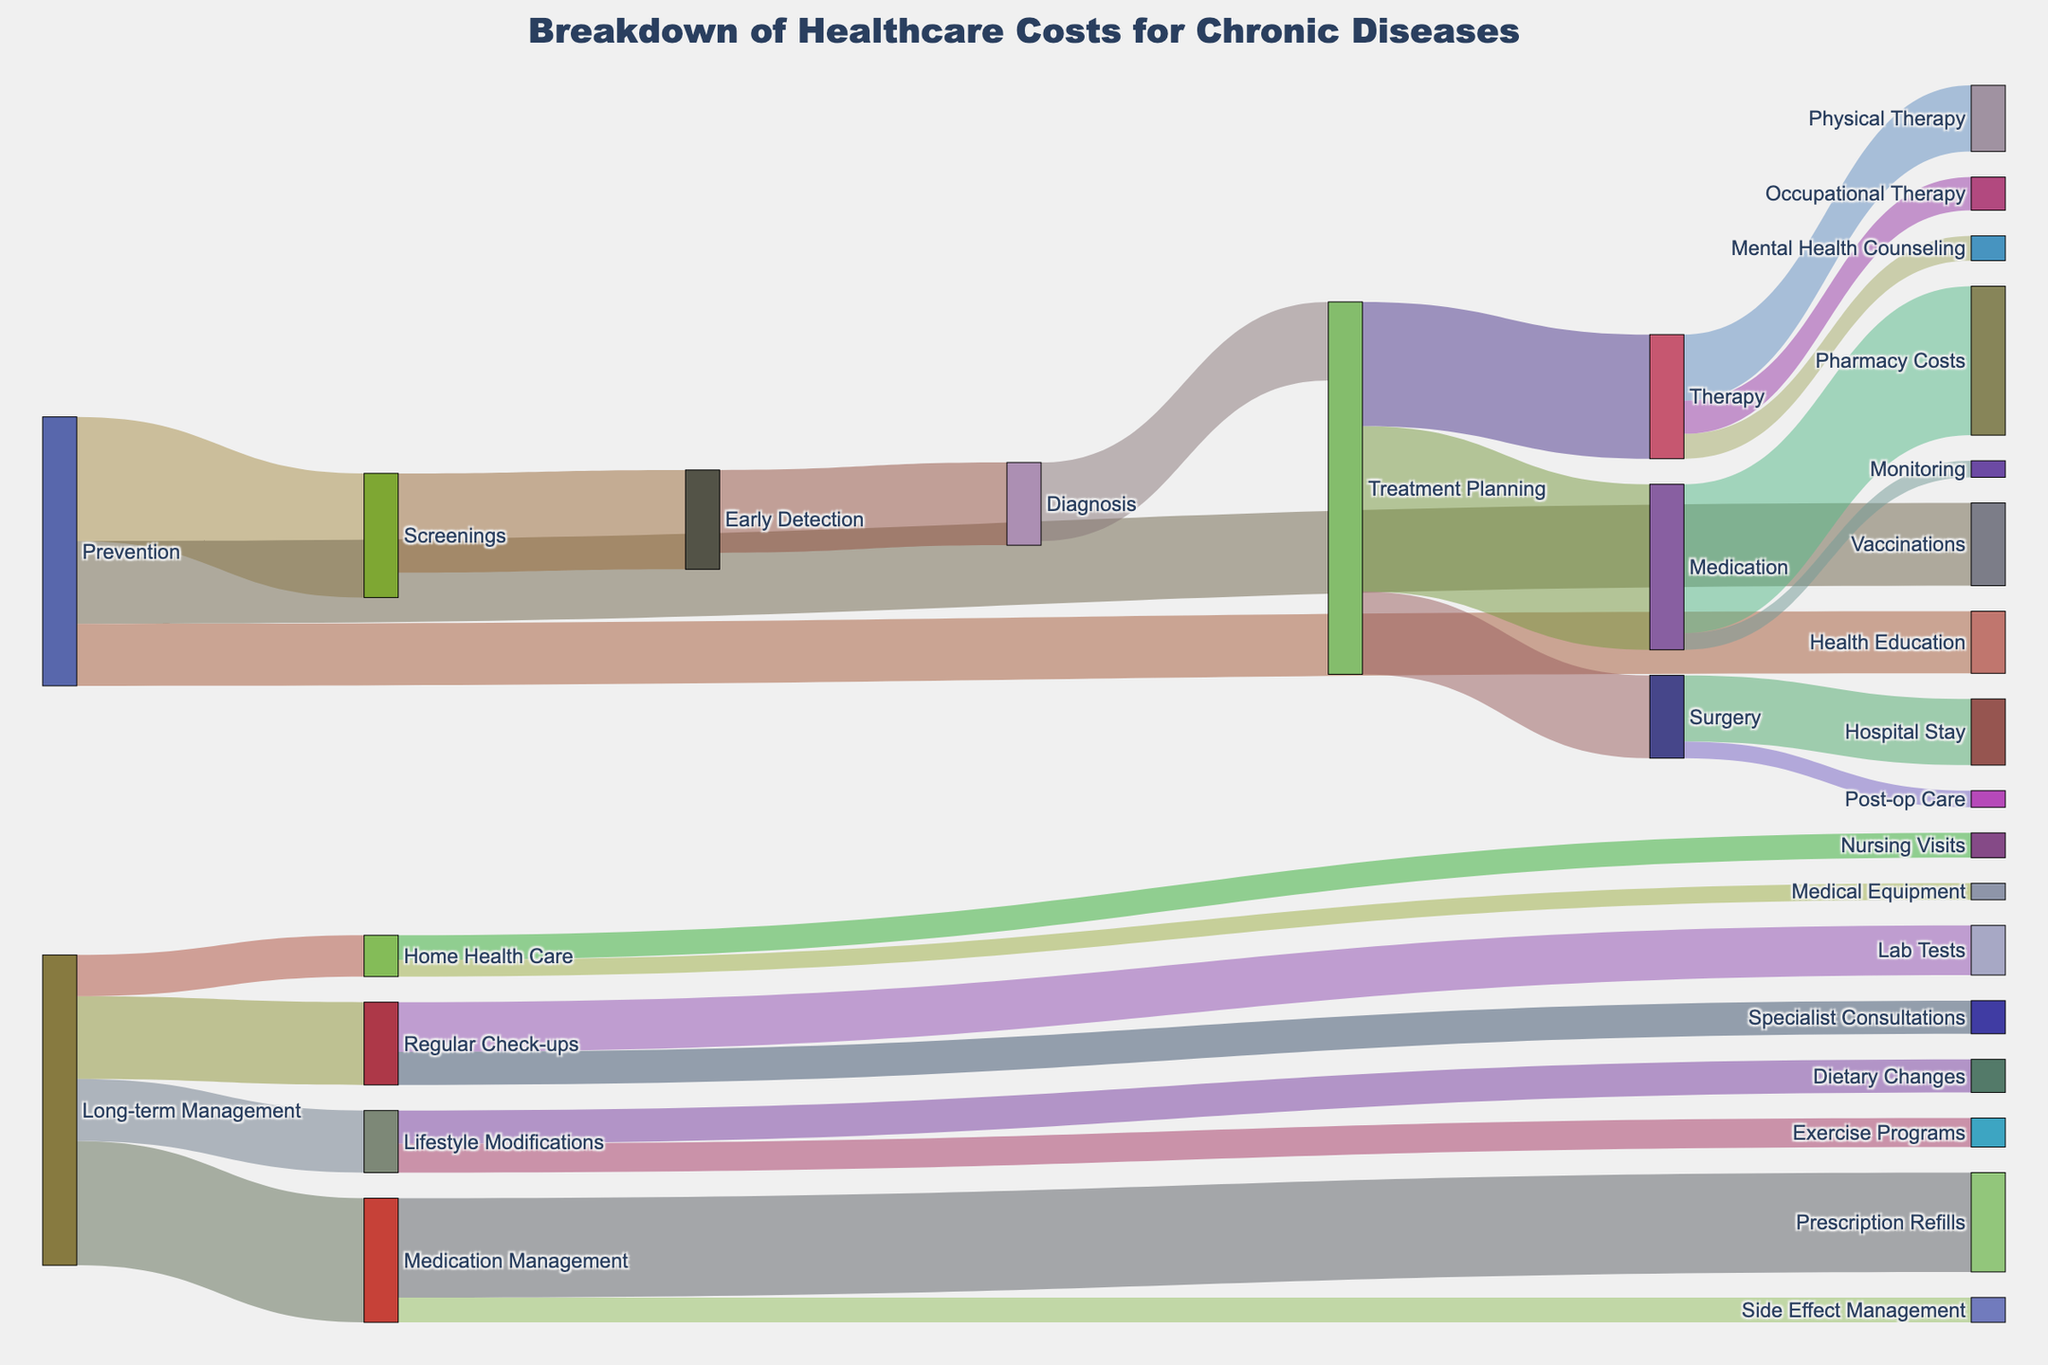What is the highest cost item within the "Long-term Management" section? First, identify the targets under "Long-term Management" which are "Regular Check-ups," "Medication Management," "Lifestyle Modifications," and "Home Health Care." The costs are 100, 150, 75, and 50 respectively. "Medication Management" has the highest cost of 150.
Answer: Medication Management What is the total cost spent on "Prevention"? Add the values of all targets linked to "Prevention": Screenings (150), Vaccinations (100), and Health Education (75). The total cost is 150 + 100 + 75 = 325.
Answer: 325 Which transition has the lowest cost within the "Therapy" section? Identify the transitions under "Therapy": Physical Therapy (80), Occupational Therapy (40), and Mental Health Counseling (30). The lowest cost is for Mental Health Counseling at 30.
Answer: Mental Health Counseling What is the total cost of "Treatment Planning"? Add the values of all targets linked to "Treatment Planning": Medication (200), Therapy (150), and Surgery (100). The total cost is 200 + 150 + 100 = 450.
Answer: 450 How does the cost of "Hospital Stay" compare to "Nursing Visits"? Identify the costs for "Hospital Stay" (80) and "Nursing Visits" (30). "Hospital Stay" is higher than "Nursing Visits".
Answer: Hospital Stay is higher What is the cumulative cost of all "Therapy" activities? Add the values of all transitions within "Therapy": Physical Therapy (80), Occupational Therapy (40), and Mental Health Counseling (30). The total cumulative cost is 80 + 40 + 30 = 150.
Answer: 150 What portion of the costs under "Medication" is attributed to "Pharmacy Costs"? Identify the costs under "Medication": Pharmacy Costs (180) and Monitoring (20). The portion attributed to Pharmacy Costs is 180 out of a total of 200, which is 180/200 = 90%.
Answer: 90% What is the cost difference between "Early Detection" and "Diagnosis"? Identify the costs for "Early Detection" (120) and "Diagnosis" (100). The difference is 120 - 100 = 20.
Answer: 20 What accounts for higher costs in "Screenings" compared to "Vaccinations"? Identify the costs for "Screenings" (150) and "Vaccinations" (100). The difference is due to screenings having a higher cost, which is 50 more than vaccinations.
Answer: Screenings are 50 more What activities follow after "Treatment Planning" and what are their individual costs? After "Treatment Planning," the activities are Medication (200), Therapy (150), and Surgery (100). These values are directly found linked from "Treatment Planning."
Answer: Medication: 200, Therapy: 150, Surgery: 100 